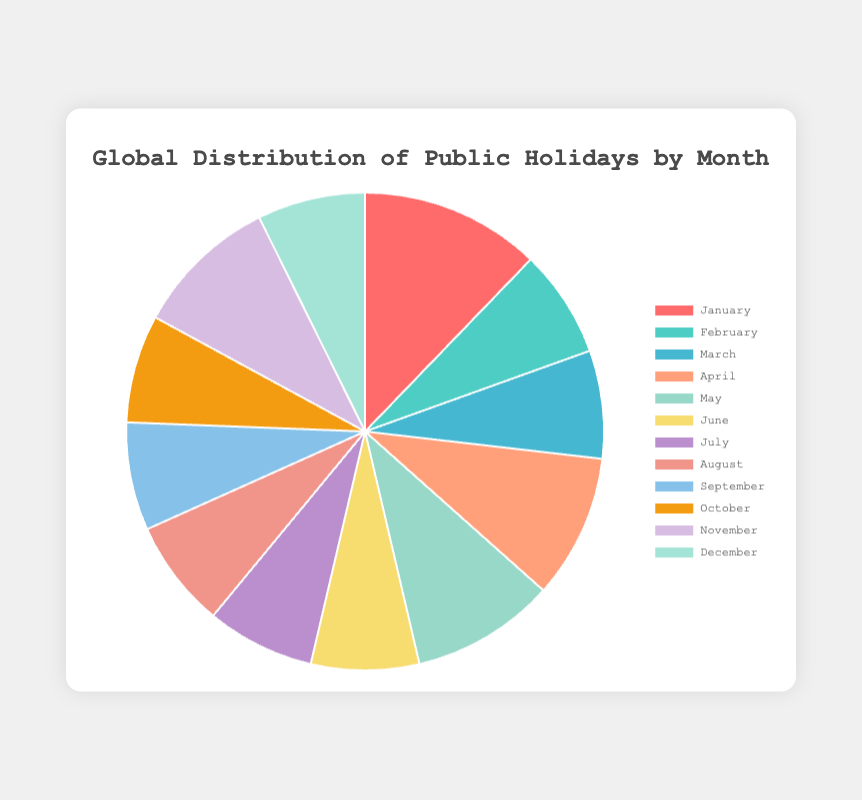Which month has the highest number of public holidays? From the pie chart, visually compare the sizes of the slices. The largest slice indicates the month with the highest number of public holidays.
Answer: January Which two months have the same number of public holidays? Look for slices of identical sizes. Refer to the tooltip when hovering over the slices for exact values.
Answer: February and March What is the total number of public holidays in the months with the fewest holidays? Identify the smallest slices in the pie chart, which represent February, March, and June. Sum the counts: 3 (each has 3 holidays).
Answer: 9 How many total holidays are there in the first quarter of the year (January - March)? Sum the counts of holidays for January, February, and March. January has 5, February 3, and March 3. The sum is 5 + 3 + 3.
Answer: 11 Is the number of holidays in November greater than in April? Compare the sizes of the slices for November and April, or check the values. November has 4 holidays, while April has 4.
Answer: Equal How does the number of holidays in the United States compare to those in Germany throughout the year? Refer to the slices for each month where the United States and Germany have holidays. Sum the total holidays per country: United States (5) and Germany (2).
Answer: United States has more What is the color of the slice representing holidays in August? Visually identify the color of the slice for August.
Answer: Green Which month has a smaller number of holidays: May or October? Compare the slice sizes for May and October. May has 4 holidays, while October has 3.
Answer: October What is the average number of public holidays per month in the pie chart? Calculate the total number of holidays and divide by the number of months. The total is 35, and there are 12 months. So, 35/12 ≈ 2.92
Answer: ~2.92 In which month do the holidays from Japan and Russia combined make up the highest count? Identify the months Japan and Russia appear and sum their holidays. January has Japan with 1 and Russia with 2, totaling 3.
Answer: January 